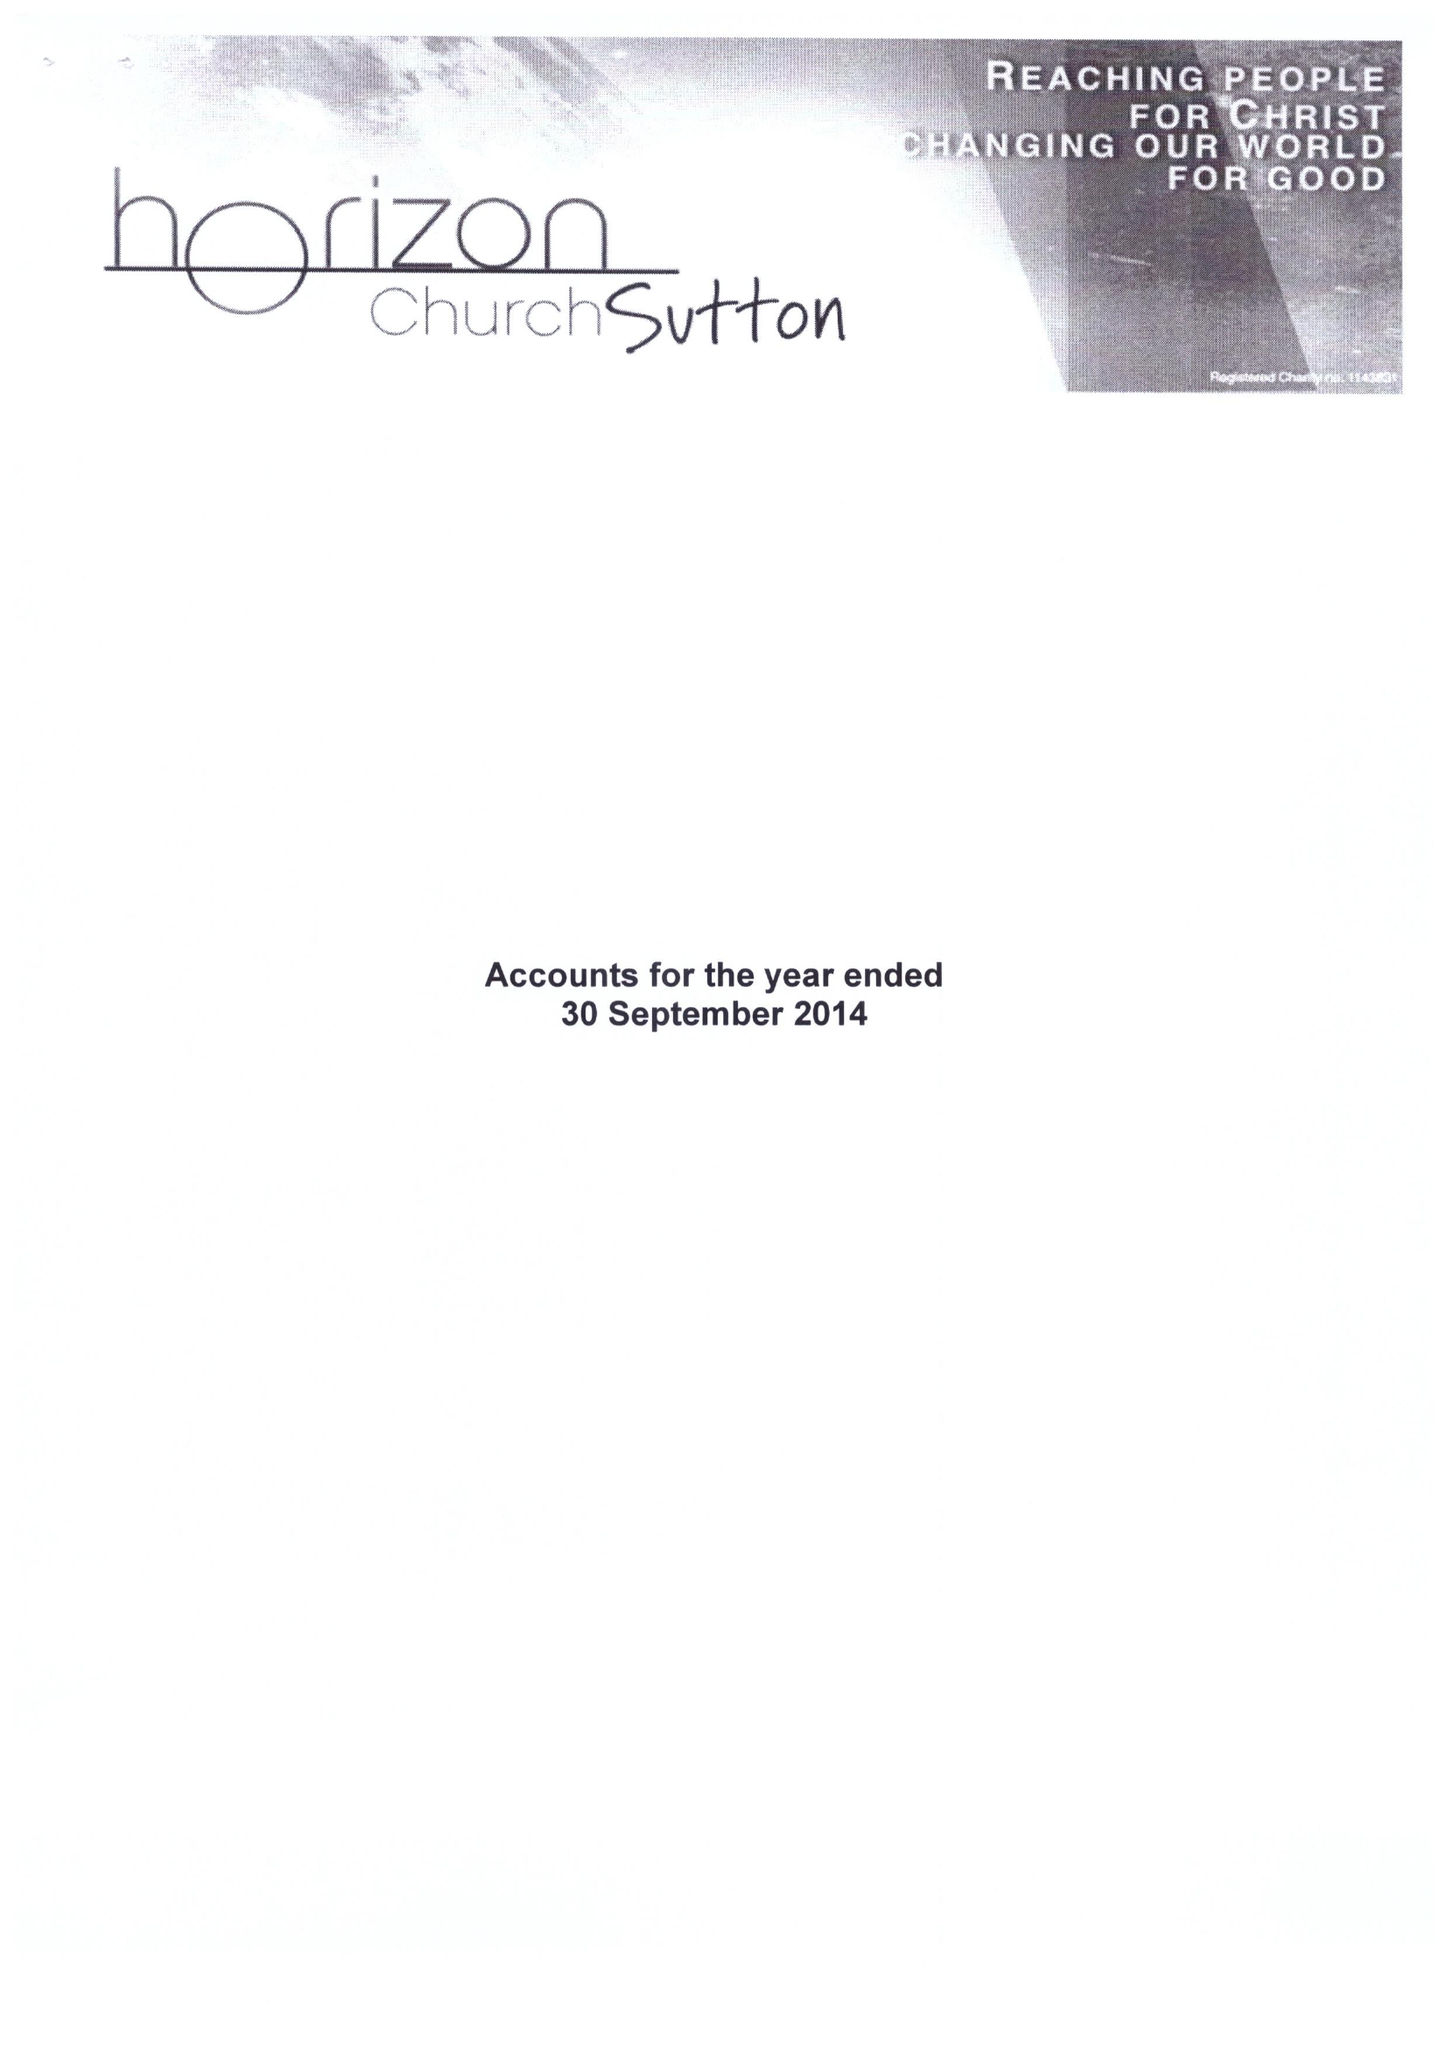What is the value for the income_annually_in_british_pounds?
Answer the question using a single word or phrase. 105036.00 